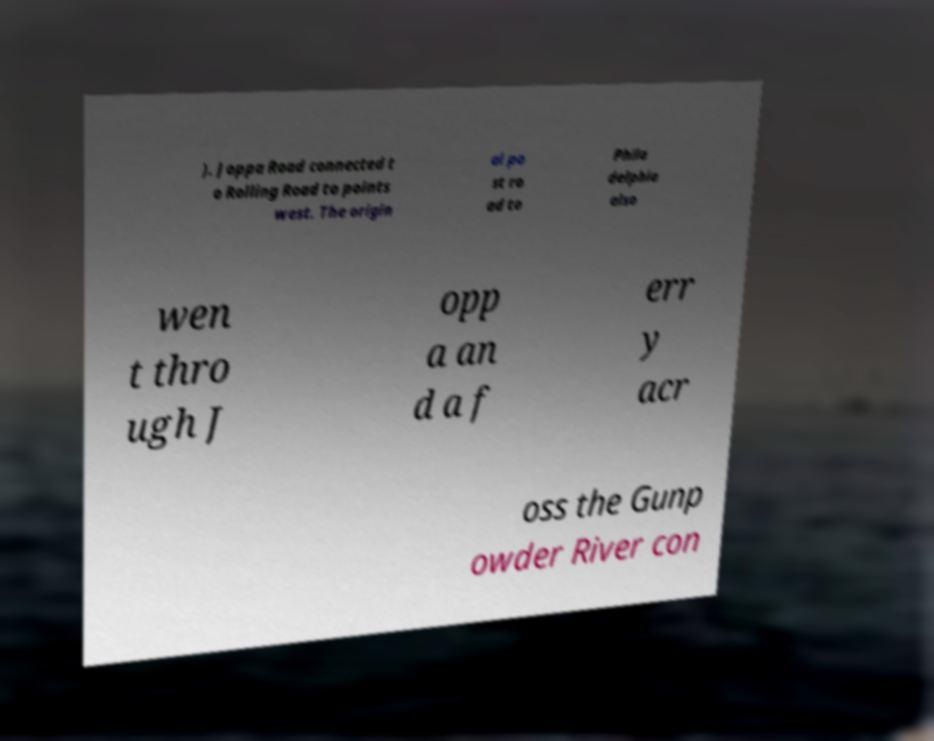I need the written content from this picture converted into text. Can you do that? ). Joppa Road connected t o Rolling Road to points west. The origin al po st ro ad to Phila delphia also wen t thro ugh J opp a an d a f err y acr oss the Gunp owder River con 